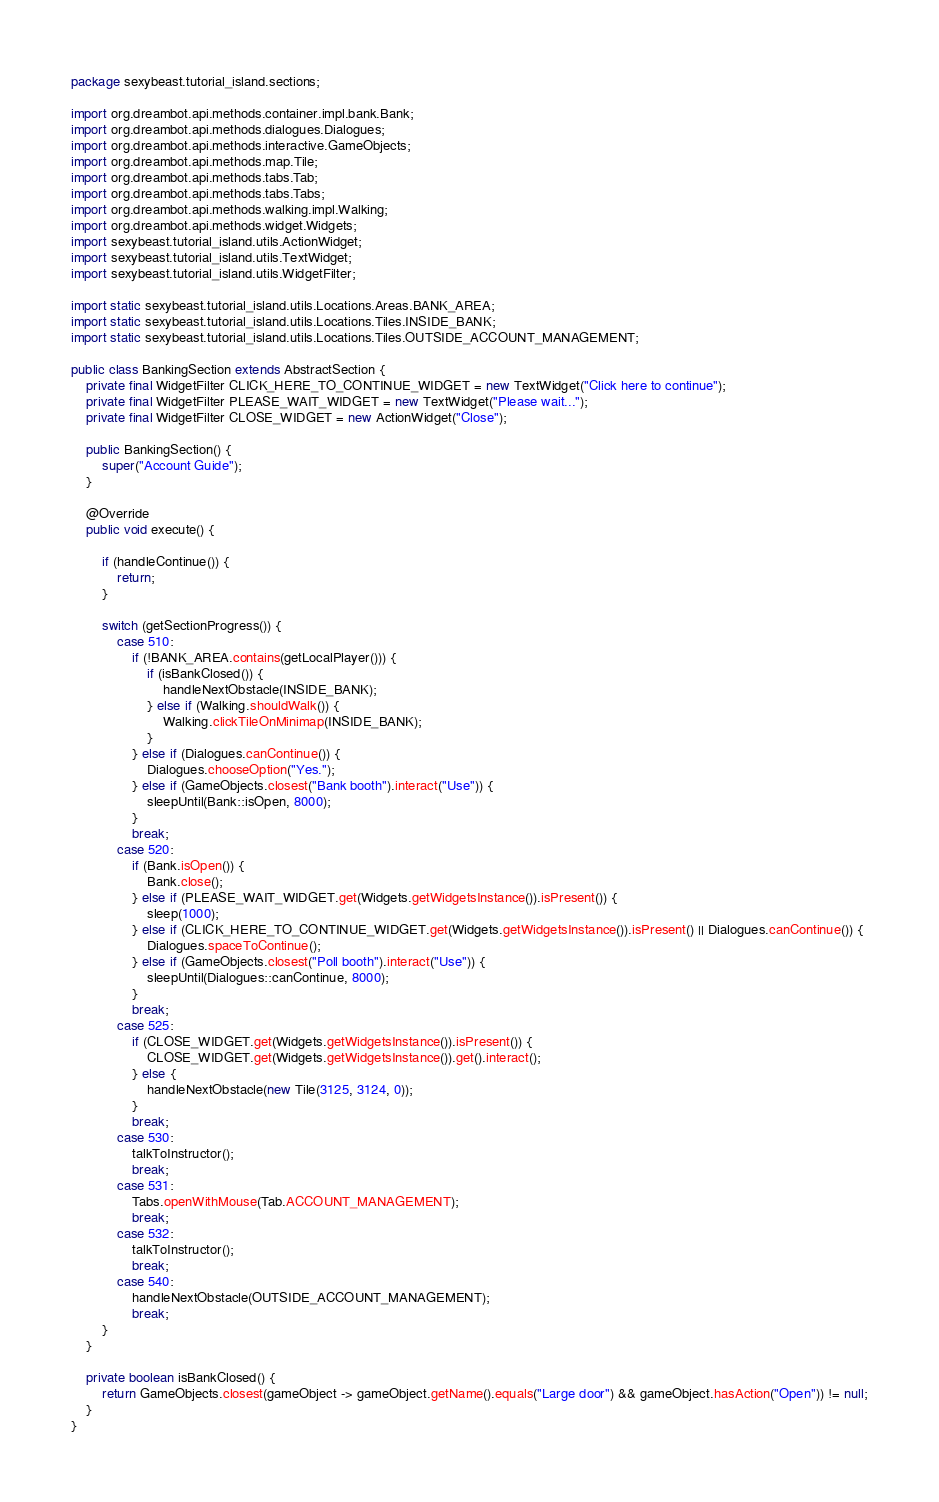<code> <loc_0><loc_0><loc_500><loc_500><_Java_>package sexybeast.tutorial_island.sections;

import org.dreambot.api.methods.container.impl.bank.Bank;
import org.dreambot.api.methods.dialogues.Dialogues;
import org.dreambot.api.methods.interactive.GameObjects;
import org.dreambot.api.methods.map.Tile;
import org.dreambot.api.methods.tabs.Tab;
import org.dreambot.api.methods.tabs.Tabs;
import org.dreambot.api.methods.walking.impl.Walking;
import org.dreambot.api.methods.widget.Widgets;
import sexybeast.tutorial_island.utils.ActionWidget;
import sexybeast.tutorial_island.utils.TextWidget;
import sexybeast.tutorial_island.utils.WidgetFilter;

import static sexybeast.tutorial_island.utils.Locations.Areas.BANK_AREA;
import static sexybeast.tutorial_island.utils.Locations.Tiles.INSIDE_BANK;
import static sexybeast.tutorial_island.utils.Locations.Tiles.OUTSIDE_ACCOUNT_MANAGEMENT;

public class BankingSection extends AbstractSection {
    private final WidgetFilter CLICK_HERE_TO_CONTINUE_WIDGET = new TextWidget("Click here to continue");
    private final WidgetFilter PLEASE_WAIT_WIDGET = new TextWidget("Please wait...");
    private final WidgetFilter CLOSE_WIDGET = new ActionWidget("Close");

    public BankingSection() {
        super("Account Guide");
    }

    @Override
    public void execute() {

        if (handleContinue()) {
            return;
        }

        switch (getSectionProgress()) {
            case 510:
                if (!BANK_AREA.contains(getLocalPlayer())) {
                    if (isBankClosed()) {
                        handleNextObstacle(INSIDE_BANK);
                    } else if (Walking.shouldWalk()) {
                        Walking.clickTileOnMinimap(INSIDE_BANK);
                    }
                } else if (Dialogues.canContinue()) {
                    Dialogues.chooseOption("Yes.");
                } else if (GameObjects.closest("Bank booth").interact("Use")) {
                    sleepUntil(Bank::isOpen, 8000);
                }
                break;
            case 520:
                if (Bank.isOpen()) {
                    Bank.close();
                } else if (PLEASE_WAIT_WIDGET.get(Widgets.getWidgetsInstance()).isPresent()) {
                    sleep(1000);
                } else if (CLICK_HERE_TO_CONTINUE_WIDGET.get(Widgets.getWidgetsInstance()).isPresent() || Dialogues.canContinue()) {
                    Dialogues.spaceToContinue();
                } else if (GameObjects.closest("Poll booth").interact("Use")) {
                    sleepUntil(Dialogues::canContinue, 8000);
                }
                break;
            case 525:
                if (CLOSE_WIDGET.get(Widgets.getWidgetsInstance()).isPresent()) {
                    CLOSE_WIDGET.get(Widgets.getWidgetsInstance()).get().interact();
                } else {
                    handleNextObstacle(new Tile(3125, 3124, 0));
                }
                break;
            case 530:
                talkToInstructor();
                break;
            case 531:
                Tabs.openWithMouse(Tab.ACCOUNT_MANAGEMENT);
                break;
            case 532:
                talkToInstructor();
                break;
            case 540:
                handleNextObstacle(OUTSIDE_ACCOUNT_MANAGEMENT);
                break;
        }
    }

    private boolean isBankClosed() {
        return GameObjects.closest(gameObject -> gameObject.getName().equals("Large door") && gameObject.hasAction("Open")) != null;
    }
}
</code> 